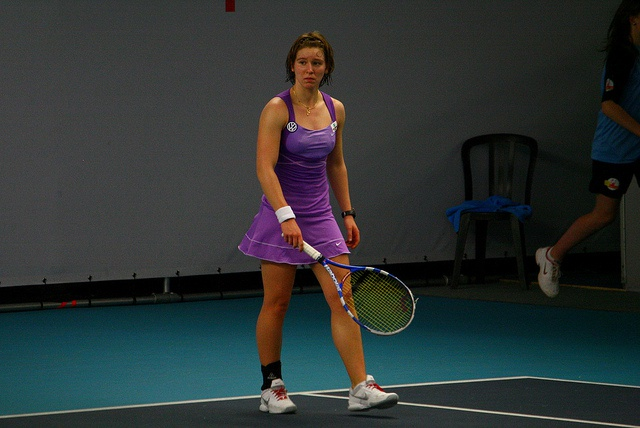Describe the objects in this image and their specific colors. I can see people in black, brown, maroon, and purple tones, people in black, gray, and maroon tones, chair in black and navy tones, and tennis racket in black, darkgreen, and brown tones in this image. 